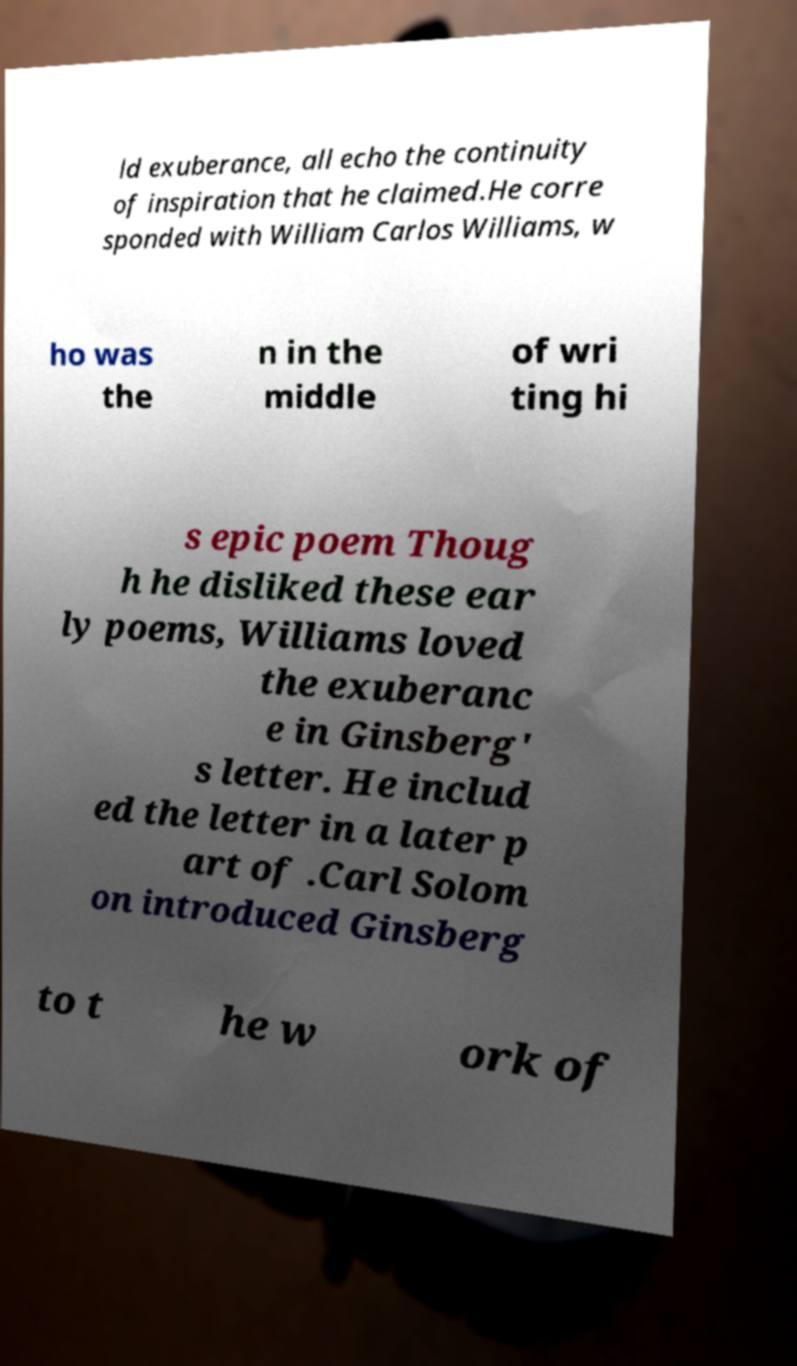Could you assist in decoding the text presented in this image and type it out clearly? ld exuberance, all echo the continuity of inspiration that he claimed.He corre sponded with William Carlos Williams, w ho was the n in the middle of wri ting hi s epic poem Thoug h he disliked these ear ly poems, Williams loved the exuberanc e in Ginsberg' s letter. He includ ed the letter in a later p art of .Carl Solom on introduced Ginsberg to t he w ork of 